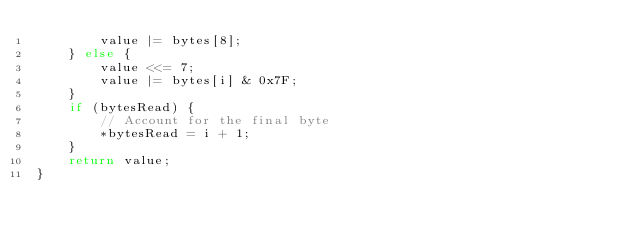<code> <loc_0><loc_0><loc_500><loc_500><_C_>        value |= bytes[8];
    } else {
        value <<= 7;
        value |= bytes[i] & 0x7F;
    }
    if (bytesRead) {
        // Account for the final byte
        *bytesRead = i + 1;
    }
    return value;
}
</code> 